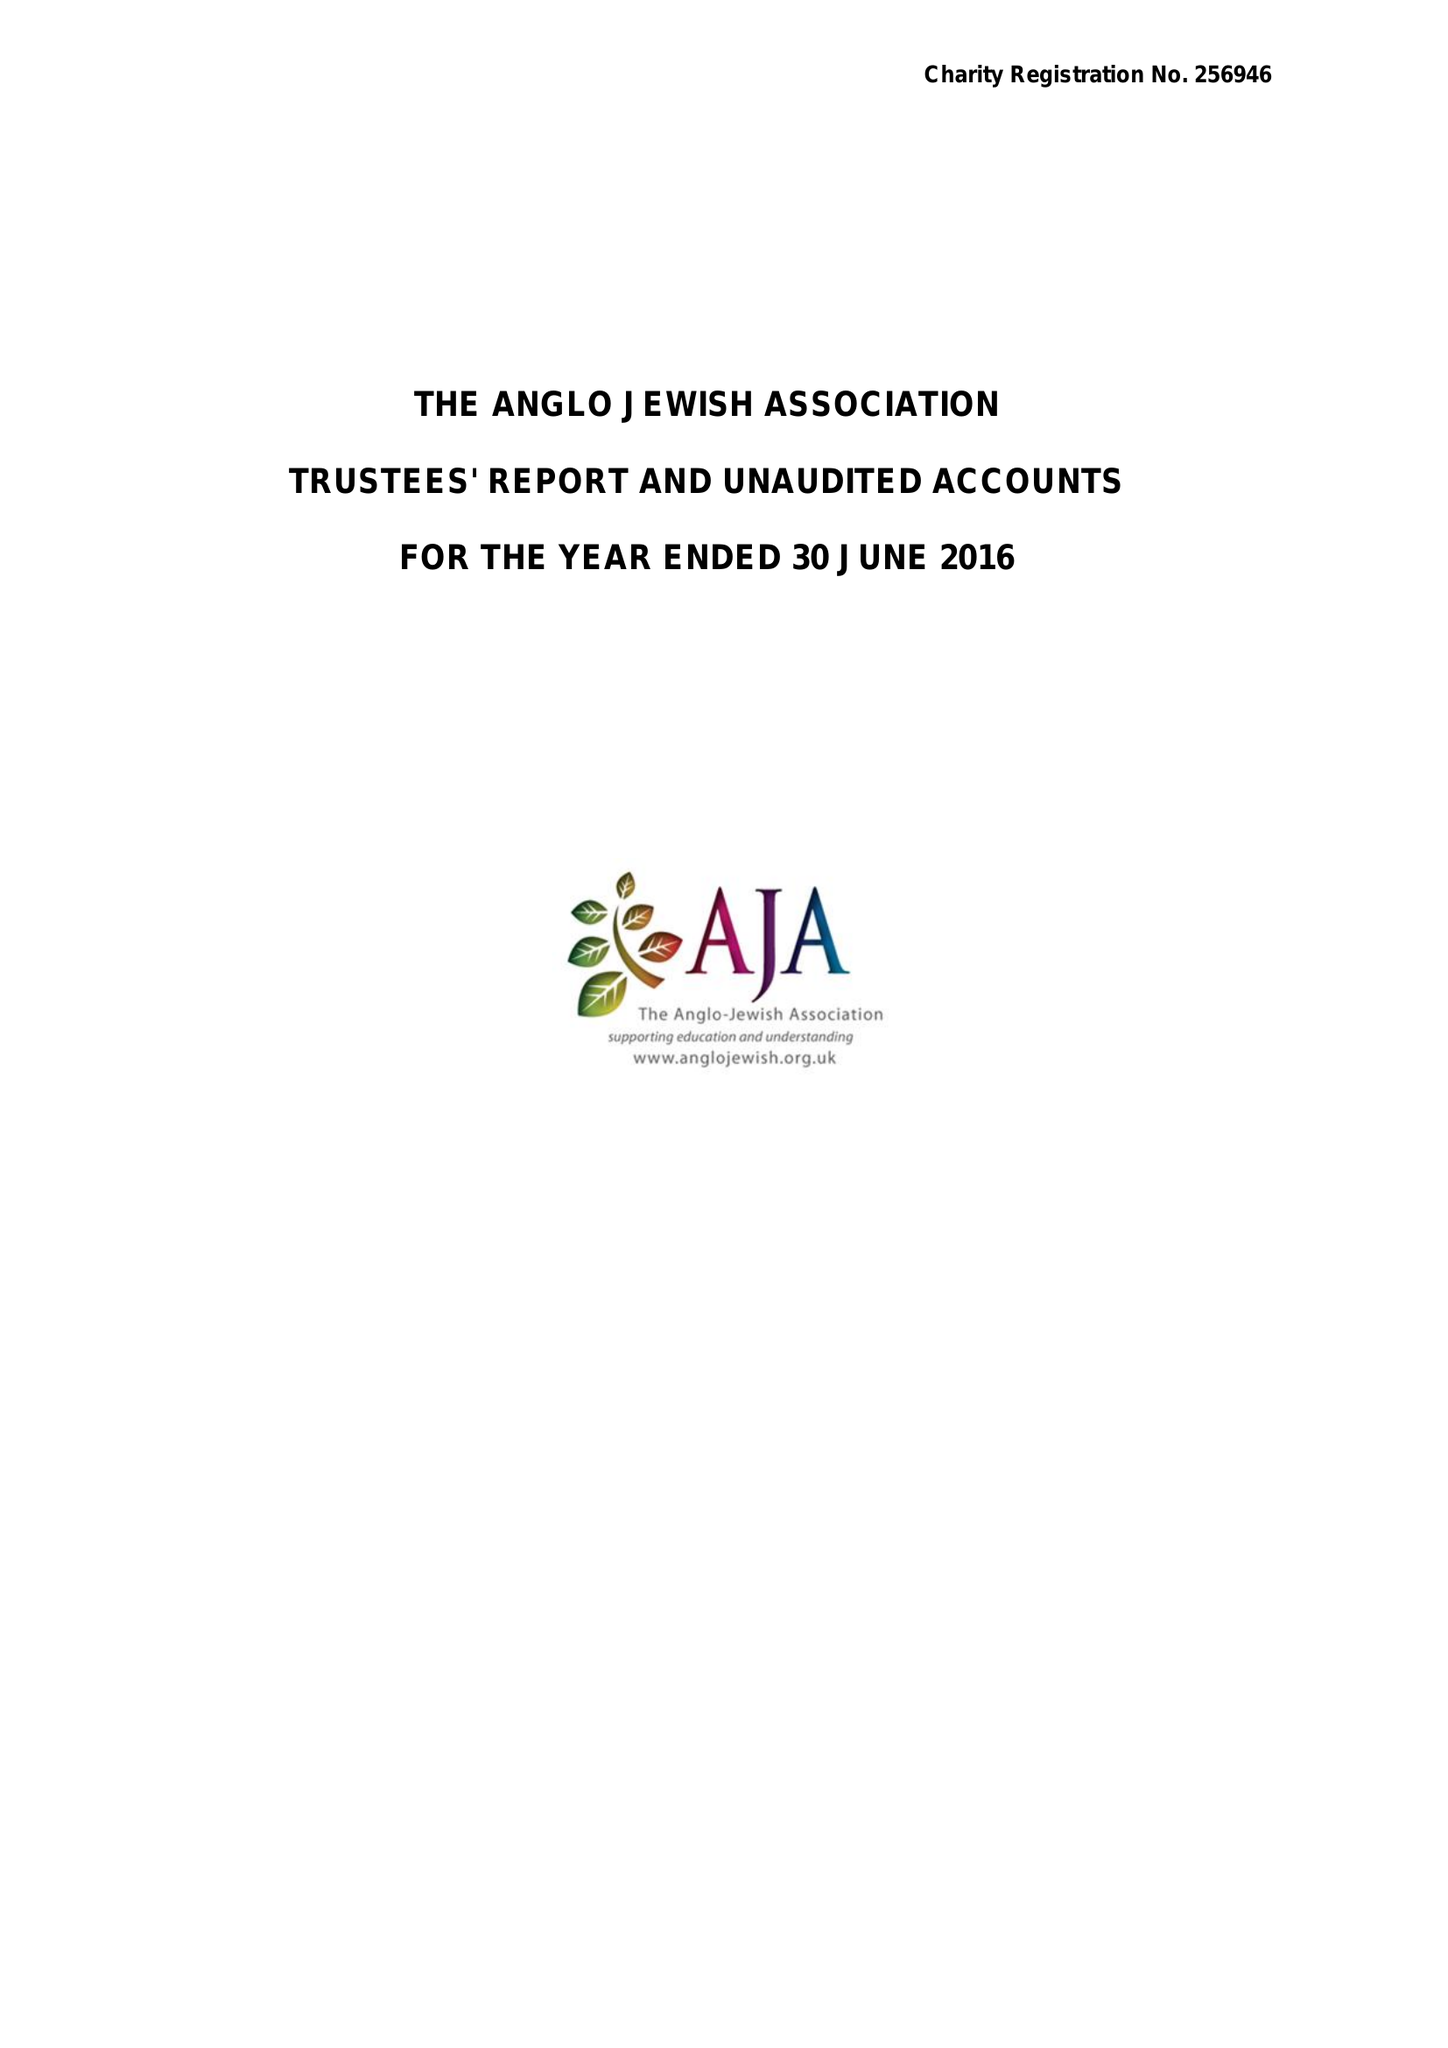What is the value for the spending_annually_in_british_pounds?
Answer the question using a single word or phrase. 93491.00 